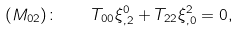<formula> <loc_0><loc_0><loc_500><loc_500>( M _ { 0 2 } ) \colon \quad T _ { 0 0 } \xi ^ { 0 } _ { , 2 } + T _ { 2 2 } \xi ^ { 2 } _ { , 0 } = 0 ,</formula> 